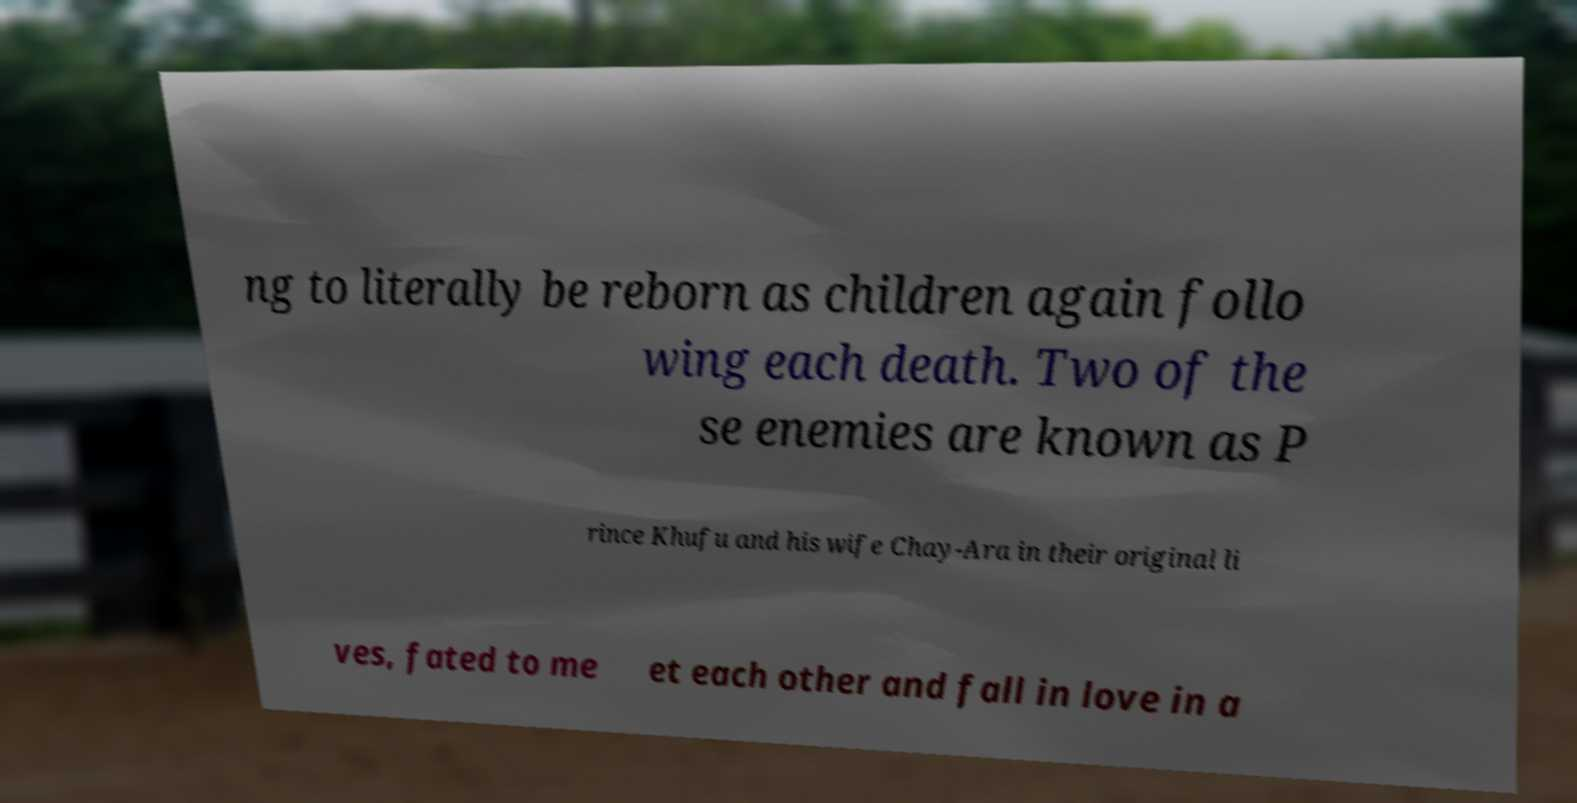For documentation purposes, I need the text within this image transcribed. Could you provide that? ng to literally be reborn as children again follo wing each death. Two of the se enemies are known as P rince Khufu and his wife Chay-Ara in their original li ves, fated to me et each other and fall in love in a 